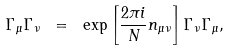<formula> <loc_0><loc_0><loc_500><loc_500>\Gamma _ { \mu } \Gamma _ { \nu } \ = \ \exp \left [ \frac { 2 \pi i } { N } n _ { \mu \nu } \right ] \Gamma _ { \nu } \Gamma _ { \mu } ,</formula> 